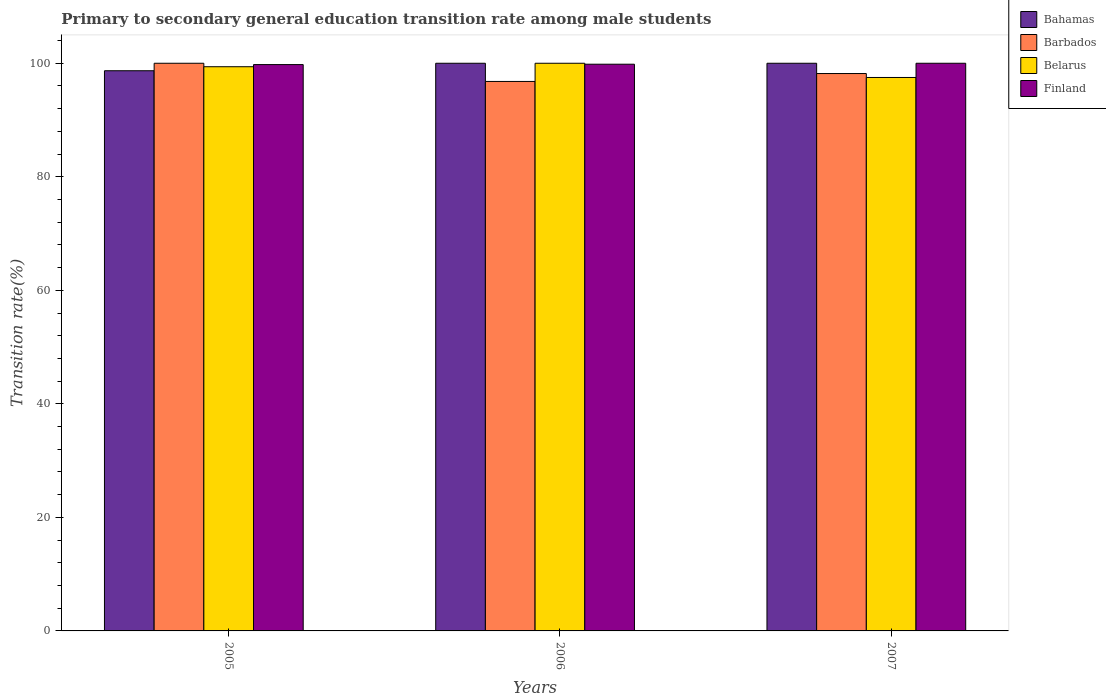How many different coloured bars are there?
Provide a short and direct response. 4. Are the number of bars on each tick of the X-axis equal?
Ensure brevity in your answer.  Yes. In how many cases, is the number of bars for a given year not equal to the number of legend labels?
Give a very brief answer. 0. What is the transition rate in Finland in 2007?
Give a very brief answer. 100. Across all years, what is the minimum transition rate in Belarus?
Provide a short and direct response. 97.49. In which year was the transition rate in Bahamas maximum?
Offer a very short reply. 2006. What is the total transition rate in Barbados in the graph?
Offer a very short reply. 294.98. What is the difference between the transition rate in Belarus in 2005 and that in 2007?
Provide a succinct answer. 1.9. What is the difference between the transition rate in Finland in 2005 and the transition rate in Barbados in 2006?
Your response must be concise. 2.97. What is the average transition rate in Finland per year?
Provide a short and direct response. 99.87. In the year 2007, what is the difference between the transition rate in Belarus and transition rate in Bahamas?
Your answer should be compact. -2.51. In how many years, is the transition rate in Belarus greater than 16 %?
Keep it short and to the point. 3. What is the ratio of the transition rate in Barbados in 2005 to that in 2007?
Keep it short and to the point. 1.02. Is the transition rate in Bahamas in 2005 less than that in 2006?
Your answer should be compact. Yes. Is the difference between the transition rate in Belarus in 2005 and 2007 greater than the difference between the transition rate in Bahamas in 2005 and 2007?
Offer a very short reply. Yes. What is the difference between the highest and the second highest transition rate in Barbados?
Ensure brevity in your answer.  1.81. What is the difference between the highest and the lowest transition rate in Belarus?
Make the answer very short. 2.51. What does the 1st bar from the left in 2007 represents?
Make the answer very short. Bahamas. What does the 2nd bar from the right in 2006 represents?
Your answer should be compact. Belarus. What is the difference between two consecutive major ticks on the Y-axis?
Provide a short and direct response. 20. Are the values on the major ticks of Y-axis written in scientific E-notation?
Offer a very short reply. No. Does the graph contain grids?
Your answer should be compact. No. What is the title of the graph?
Ensure brevity in your answer.  Primary to secondary general education transition rate among male students. Does "Benin" appear as one of the legend labels in the graph?
Make the answer very short. No. What is the label or title of the Y-axis?
Keep it short and to the point. Transition rate(%). What is the Transition rate(%) in Bahamas in 2005?
Keep it short and to the point. 98.68. What is the Transition rate(%) in Barbados in 2005?
Ensure brevity in your answer.  100. What is the Transition rate(%) of Belarus in 2005?
Ensure brevity in your answer.  99.39. What is the Transition rate(%) of Finland in 2005?
Ensure brevity in your answer.  99.77. What is the Transition rate(%) in Bahamas in 2006?
Your answer should be compact. 100. What is the Transition rate(%) of Barbados in 2006?
Your answer should be compact. 96.8. What is the Transition rate(%) in Belarus in 2006?
Give a very brief answer. 100. What is the Transition rate(%) in Finland in 2006?
Provide a short and direct response. 99.83. What is the Transition rate(%) of Bahamas in 2007?
Make the answer very short. 100. What is the Transition rate(%) in Barbados in 2007?
Your response must be concise. 98.19. What is the Transition rate(%) of Belarus in 2007?
Offer a terse response. 97.49. What is the Transition rate(%) of Finland in 2007?
Make the answer very short. 100. Across all years, what is the maximum Transition rate(%) of Bahamas?
Offer a very short reply. 100. Across all years, what is the minimum Transition rate(%) of Bahamas?
Your answer should be very brief. 98.68. Across all years, what is the minimum Transition rate(%) in Barbados?
Your answer should be very brief. 96.8. Across all years, what is the minimum Transition rate(%) of Belarus?
Keep it short and to the point. 97.49. Across all years, what is the minimum Transition rate(%) in Finland?
Offer a very short reply. 99.77. What is the total Transition rate(%) of Bahamas in the graph?
Offer a terse response. 298.68. What is the total Transition rate(%) of Barbados in the graph?
Provide a short and direct response. 294.98. What is the total Transition rate(%) of Belarus in the graph?
Your answer should be very brief. 296.89. What is the total Transition rate(%) in Finland in the graph?
Your answer should be very brief. 299.6. What is the difference between the Transition rate(%) of Bahamas in 2005 and that in 2006?
Ensure brevity in your answer.  -1.32. What is the difference between the Transition rate(%) in Barbados in 2005 and that in 2006?
Your answer should be very brief. 3.2. What is the difference between the Transition rate(%) in Belarus in 2005 and that in 2006?
Your response must be concise. -0.61. What is the difference between the Transition rate(%) of Finland in 2005 and that in 2006?
Your response must be concise. -0.07. What is the difference between the Transition rate(%) of Bahamas in 2005 and that in 2007?
Give a very brief answer. -1.32. What is the difference between the Transition rate(%) in Barbados in 2005 and that in 2007?
Offer a terse response. 1.81. What is the difference between the Transition rate(%) of Belarus in 2005 and that in 2007?
Provide a short and direct response. 1.9. What is the difference between the Transition rate(%) of Finland in 2005 and that in 2007?
Your answer should be compact. -0.23. What is the difference between the Transition rate(%) of Bahamas in 2006 and that in 2007?
Make the answer very short. 0. What is the difference between the Transition rate(%) of Barbados in 2006 and that in 2007?
Make the answer very short. -1.39. What is the difference between the Transition rate(%) of Belarus in 2006 and that in 2007?
Your response must be concise. 2.51. What is the difference between the Transition rate(%) of Finland in 2006 and that in 2007?
Offer a very short reply. -0.17. What is the difference between the Transition rate(%) in Bahamas in 2005 and the Transition rate(%) in Barbados in 2006?
Offer a terse response. 1.89. What is the difference between the Transition rate(%) of Bahamas in 2005 and the Transition rate(%) of Belarus in 2006?
Offer a terse response. -1.32. What is the difference between the Transition rate(%) in Bahamas in 2005 and the Transition rate(%) in Finland in 2006?
Keep it short and to the point. -1.15. What is the difference between the Transition rate(%) of Barbados in 2005 and the Transition rate(%) of Finland in 2006?
Make the answer very short. 0.17. What is the difference between the Transition rate(%) of Belarus in 2005 and the Transition rate(%) of Finland in 2006?
Your answer should be compact. -0.44. What is the difference between the Transition rate(%) of Bahamas in 2005 and the Transition rate(%) of Barbados in 2007?
Your answer should be very brief. 0.49. What is the difference between the Transition rate(%) in Bahamas in 2005 and the Transition rate(%) in Belarus in 2007?
Provide a succinct answer. 1.19. What is the difference between the Transition rate(%) in Bahamas in 2005 and the Transition rate(%) in Finland in 2007?
Make the answer very short. -1.32. What is the difference between the Transition rate(%) in Barbados in 2005 and the Transition rate(%) in Belarus in 2007?
Offer a terse response. 2.51. What is the difference between the Transition rate(%) in Barbados in 2005 and the Transition rate(%) in Finland in 2007?
Keep it short and to the point. 0. What is the difference between the Transition rate(%) of Belarus in 2005 and the Transition rate(%) of Finland in 2007?
Give a very brief answer. -0.61. What is the difference between the Transition rate(%) of Bahamas in 2006 and the Transition rate(%) of Barbados in 2007?
Ensure brevity in your answer.  1.81. What is the difference between the Transition rate(%) of Bahamas in 2006 and the Transition rate(%) of Belarus in 2007?
Offer a terse response. 2.51. What is the difference between the Transition rate(%) in Barbados in 2006 and the Transition rate(%) in Belarus in 2007?
Make the answer very short. -0.7. What is the difference between the Transition rate(%) in Barbados in 2006 and the Transition rate(%) in Finland in 2007?
Provide a short and direct response. -3.2. What is the average Transition rate(%) of Bahamas per year?
Keep it short and to the point. 99.56. What is the average Transition rate(%) of Barbados per year?
Provide a succinct answer. 98.33. What is the average Transition rate(%) of Belarus per year?
Your answer should be very brief. 98.96. What is the average Transition rate(%) of Finland per year?
Ensure brevity in your answer.  99.87. In the year 2005, what is the difference between the Transition rate(%) of Bahamas and Transition rate(%) of Barbados?
Your answer should be very brief. -1.32. In the year 2005, what is the difference between the Transition rate(%) of Bahamas and Transition rate(%) of Belarus?
Ensure brevity in your answer.  -0.71. In the year 2005, what is the difference between the Transition rate(%) in Bahamas and Transition rate(%) in Finland?
Keep it short and to the point. -1.08. In the year 2005, what is the difference between the Transition rate(%) of Barbados and Transition rate(%) of Belarus?
Ensure brevity in your answer.  0.61. In the year 2005, what is the difference between the Transition rate(%) in Barbados and Transition rate(%) in Finland?
Your answer should be compact. 0.23. In the year 2005, what is the difference between the Transition rate(%) of Belarus and Transition rate(%) of Finland?
Offer a very short reply. -0.38. In the year 2006, what is the difference between the Transition rate(%) in Bahamas and Transition rate(%) in Barbados?
Keep it short and to the point. 3.2. In the year 2006, what is the difference between the Transition rate(%) of Bahamas and Transition rate(%) of Finland?
Make the answer very short. 0.17. In the year 2006, what is the difference between the Transition rate(%) of Barbados and Transition rate(%) of Belarus?
Offer a very short reply. -3.2. In the year 2006, what is the difference between the Transition rate(%) in Barbados and Transition rate(%) in Finland?
Your response must be concise. -3.04. In the year 2006, what is the difference between the Transition rate(%) of Belarus and Transition rate(%) of Finland?
Your answer should be very brief. 0.17. In the year 2007, what is the difference between the Transition rate(%) in Bahamas and Transition rate(%) in Barbados?
Offer a terse response. 1.81. In the year 2007, what is the difference between the Transition rate(%) of Bahamas and Transition rate(%) of Belarus?
Ensure brevity in your answer.  2.51. In the year 2007, what is the difference between the Transition rate(%) of Barbados and Transition rate(%) of Belarus?
Your answer should be very brief. 0.69. In the year 2007, what is the difference between the Transition rate(%) in Barbados and Transition rate(%) in Finland?
Your answer should be compact. -1.81. In the year 2007, what is the difference between the Transition rate(%) of Belarus and Transition rate(%) of Finland?
Provide a succinct answer. -2.51. What is the ratio of the Transition rate(%) in Bahamas in 2005 to that in 2006?
Your answer should be very brief. 0.99. What is the ratio of the Transition rate(%) in Barbados in 2005 to that in 2006?
Offer a very short reply. 1.03. What is the ratio of the Transition rate(%) in Belarus in 2005 to that in 2006?
Offer a terse response. 0.99. What is the ratio of the Transition rate(%) in Finland in 2005 to that in 2006?
Your response must be concise. 1. What is the ratio of the Transition rate(%) in Barbados in 2005 to that in 2007?
Make the answer very short. 1.02. What is the ratio of the Transition rate(%) in Belarus in 2005 to that in 2007?
Keep it short and to the point. 1.02. What is the ratio of the Transition rate(%) of Finland in 2005 to that in 2007?
Offer a terse response. 1. What is the ratio of the Transition rate(%) in Barbados in 2006 to that in 2007?
Provide a short and direct response. 0.99. What is the ratio of the Transition rate(%) in Belarus in 2006 to that in 2007?
Ensure brevity in your answer.  1.03. What is the ratio of the Transition rate(%) in Finland in 2006 to that in 2007?
Offer a terse response. 1. What is the difference between the highest and the second highest Transition rate(%) of Barbados?
Provide a short and direct response. 1.81. What is the difference between the highest and the second highest Transition rate(%) in Belarus?
Ensure brevity in your answer.  0.61. What is the difference between the highest and the second highest Transition rate(%) of Finland?
Your answer should be very brief. 0.17. What is the difference between the highest and the lowest Transition rate(%) of Bahamas?
Your answer should be very brief. 1.32. What is the difference between the highest and the lowest Transition rate(%) in Barbados?
Your answer should be compact. 3.2. What is the difference between the highest and the lowest Transition rate(%) of Belarus?
Give a very brief answer. 2.51. What is the difference between the highest and the lowest Transition rate(%) of Finland?
Provide a short and direct response. 0.23. 